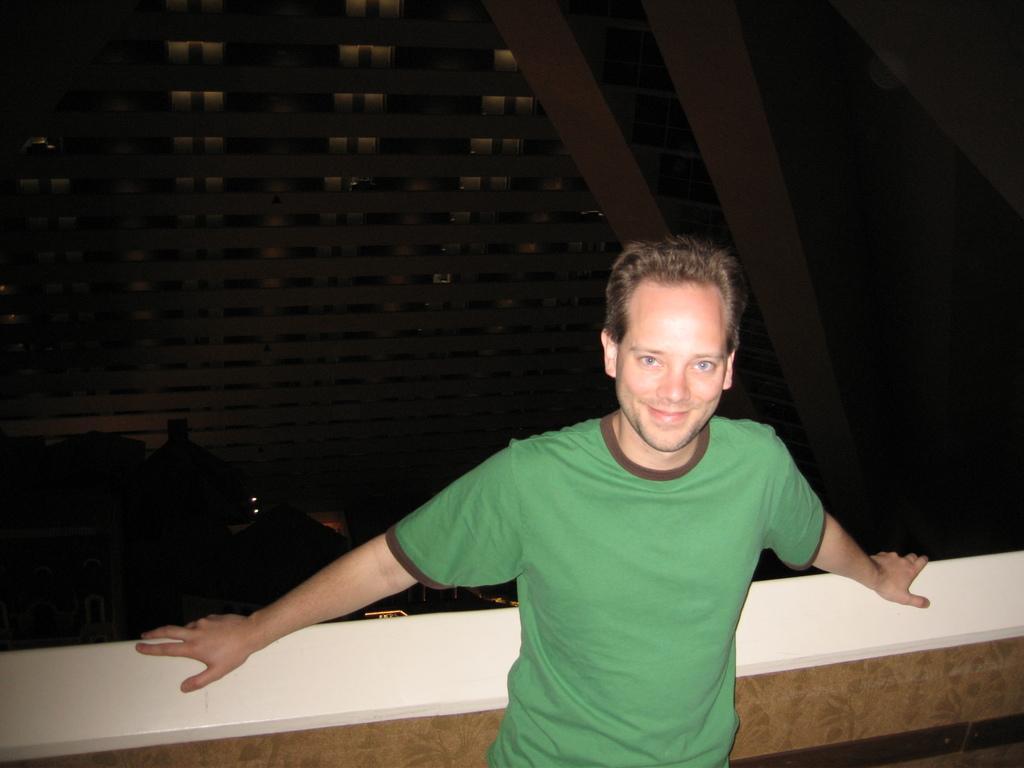Can you describe this image briefly? In the image I can see a person who is standing in front of the wall and behind there is a building. 